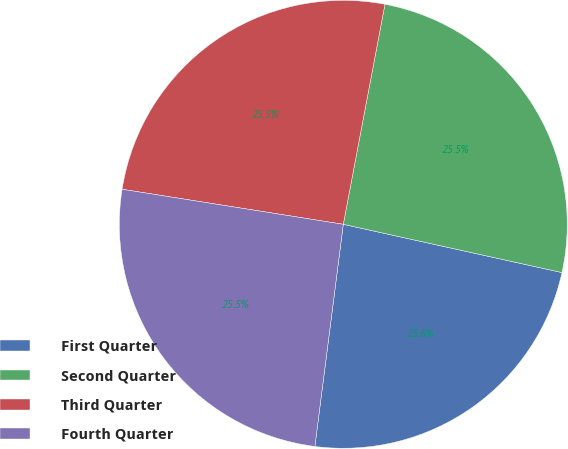<chart> <loc_0><loc_0><loc_500><loc_500><pie_chart><fcel>First Quarter<fcel>Second Quarter<fcel>Third Quarter<fcel>Fourth Quarter<nl><fcel>23.57%<fcel>25.48%<fcel>25.48%<fcel>25.48%<nl></chart> 